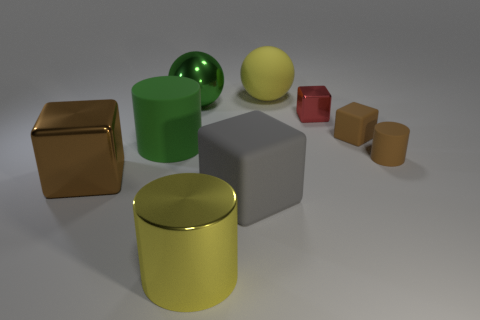Subtract all gray cubes. How many cubes are left? 3 Subtract all rubber cylinders. How many cylinders are left? 1 Add 1 large gray objects. How many objects exist? 10 Subtract all purple blocks. Subtract all cyan cylinders. How many blocks are left? 4 Add 2 big metal cylinders. How many big metal cylinders are left? 3 Add 5 brown rubber blocks. How many brown rubber blocks exist? 6 Subtract 0 purple cylinders. How many objects are left? 9 Subtract all cylinders. How many objects are left? 6 Subtract all large metallic balls. Subtract all yellow shiny things. How many objects are left? 7 